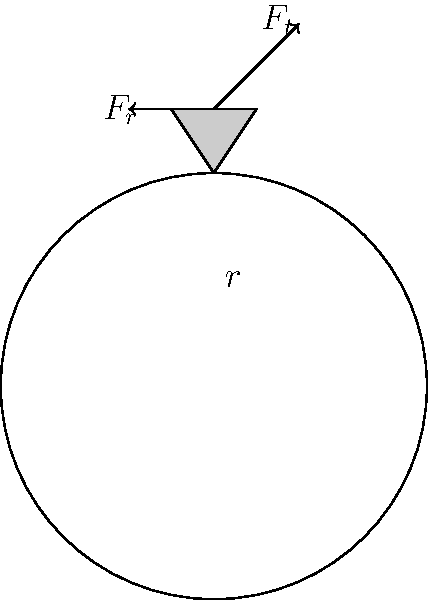In a spur gear system, a gear with a pitch radius $r = 50$ mm is subjected to a tangential force $F_t = 1000$ N at the pitch circle. Calculate the radial force $F_r$ acting on the gear tooth, assuming a pressure angle of 20°. Additionally, determine the bending stress $\sigma$ at the base of the tooth if the tooth is modeled as a cantilever beam with a face width of 10 mm and a thickness of 8 mm at the base. To solve this problem, we'll follow these steps:

1. Calculate the radial force $F_r$:
   The radial force is related to the tangential force by the pressure angle:
   $$F_r = F_t \tan(\theta)$$
   where $\theta$ is the pressure angle.
   $$F_r = 1000 \tan(20°) = 1000 \cdot 0.3640 = 364 \text{ N}$$

2. Calculate the bending moment at the base of the tooth:
   Assuming the force acts at the tip of the tooth, and the tooth height is approximately equal to the module (which is typically $2.25$ times the tooth thickness):
   $$\text{Tooth height} \approx 2.25 \cdot 8 \text{ mm} = 18 \text{ mm}$$
   The bending moment is:
   $$M = F_t \cdot 18 \text{ mm} = 1000 \text{ N} \cdot 0.018 \text{ m} = 18 \text{ N·m}$$

3. Calculate the section modulus of the tooth base:
   For a rectangular cross-section:
   $$Z = \frac{1}{6} \cdot \text{width} \cdot \text{thickness}^2 = \frac{1}{6} \cdot 10 \text{ mm} \cdot (8 \text{ mm})^2 = 106.67 \text{ mm}^3$$

4. Calculate the bending stress:
   $$\sigma = \frac{M}{Z} = \frac{18 \text{ N·m}}{106.67 \cdot 10^{-9} \text{ m}^3} = 168.75 \text{ MPa}$$
Answer: $F_r = 364 \text{ N}$, $\sigma = 168.75 \text{ MPa}$ 